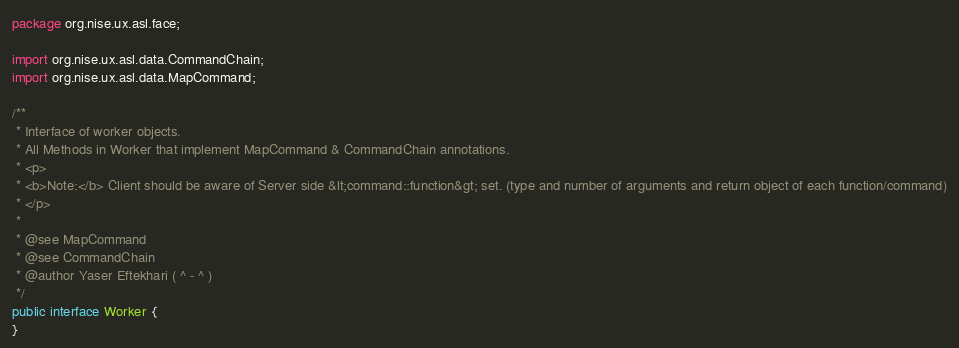<code> <loc_0><loc_0><loc_500><loc_500><_Java_>package org.nise.ux.asl.face;

import org.nise.ux.asl.data.CommandChain;
import org.nise.ux.asl.data.MapCommand;

/**
 * Interface of worker objects.
 * All Methods in Worker that implement MapCommand & CommandChain annotations.
 * <p>
 * <b>Note:</b> Client should be aware of Server side &lt;command::function&gt; set. (type and number of arguments and return object of each function/command)
 * </p>
 * 
 * @see MapCommand
 * @see CommandChain
 * @author Yaser Eftekhari ( ^ - ^ )
 */
public interface Worker {
}</code> 